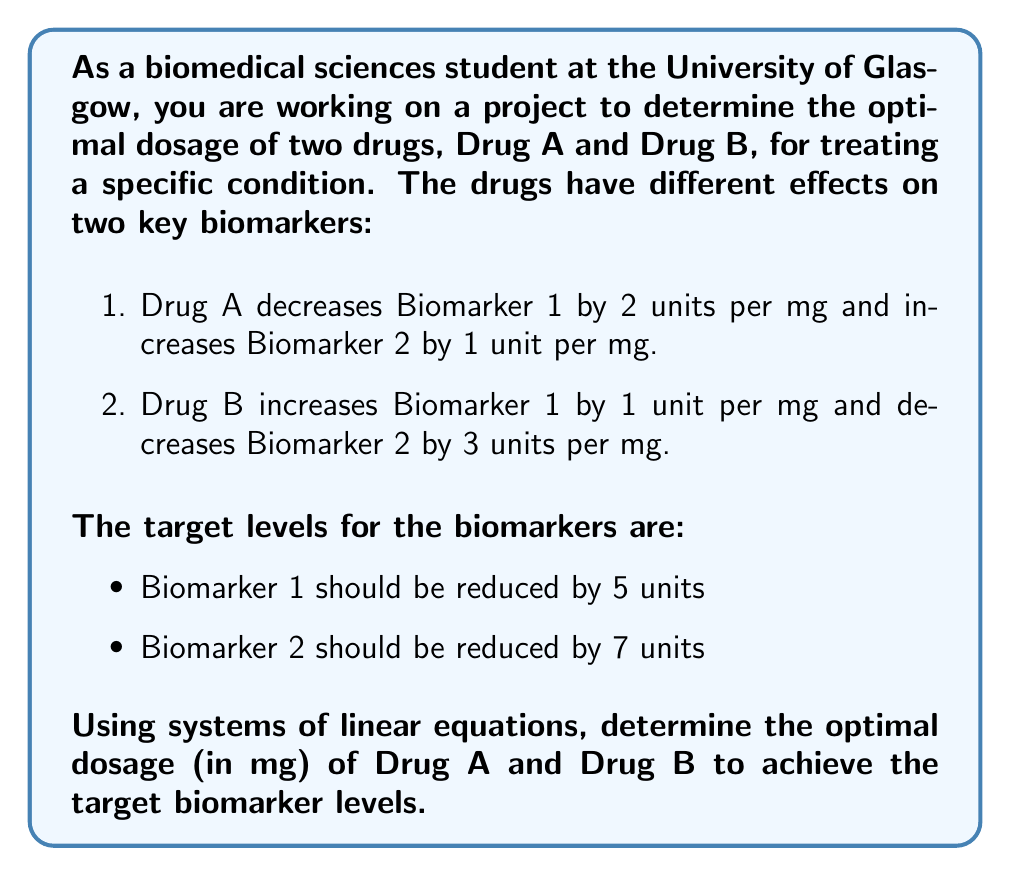Can you answer this question? To solve this problem, we need to set up a system of linear equations based on the given information:

Let $x$ be the dosage of Drug A in mg
Let $y$ be the dosage of Drug B in mg

For Biomarker 1:
$$ -2x + y = -5 $$

For Biomarker 2:
$$ x - 3y = -7 $$

Now we have a system of two linear equations with two unknowns:

$$ \begin{cases}
-2x + y = -5 \\
x - 3y = -7
\end{cases} $$

To solve this system, we can use the elimination method:

1. Multiply the first equation by 3 and the second equation by 1:
   $$ \begin{cases}
   -6x + 3y = -15 \\
   x - 3y = -7
   \end{cases} $$

2. Add the two equations to eliminate y:
   $$ -5x = -22 $$

3. Solve for x:
   $$ x = \frac{22}{5} = 4.4 $$

4. Substitute x back into one of the original equations to solve for y:
   $$ -2(4.4) + y = -5 $$
   $$ -8.8 + y = -5 $$
   $$ y = 3.8 $$

Therefore, the optimal dosage is 4.4 mg of Drug A and 3.8 mg of Drug B.

To verify:
For Biomarker 1: $-2(4.4) + 3.8 = -8.8 + 3.8 = -5$
For Biomarker 2: $4.4 - 3(3.8) = 4.4 - 11.4 = -7$

Both equations are satisfied, confirming our solution.
Answer: The optimal dosage is 4.4 mg of Drug A and 3.8 mg of Drug B. 